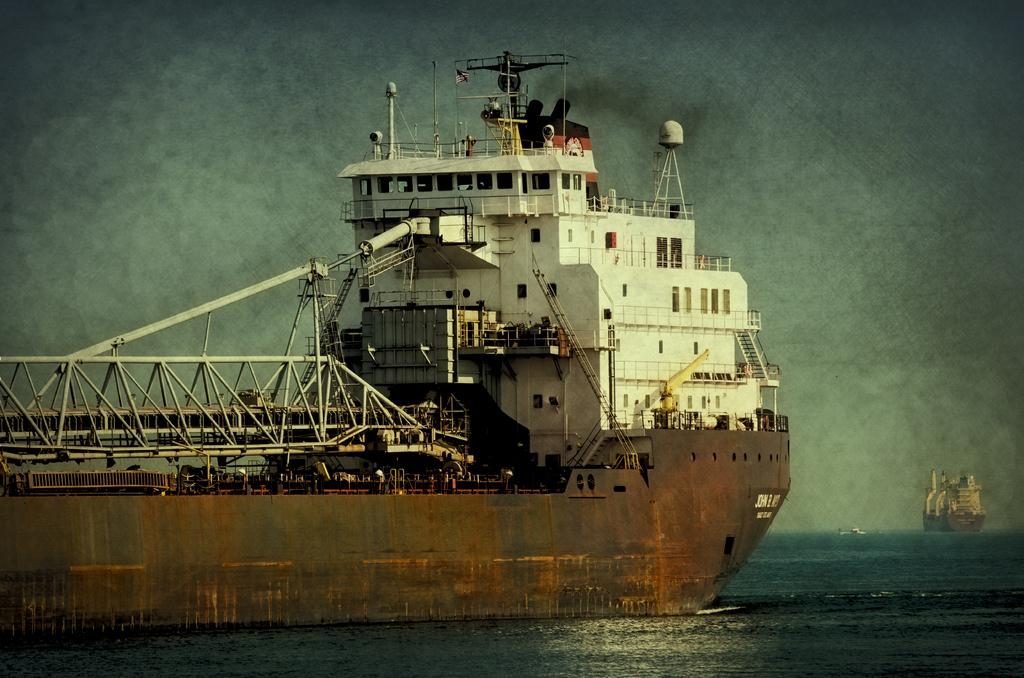What are the people in the image doing? The people in the image are in a boat. What is the primary setting of the image? There is water visible in the image. What else can be seen in the sky? There is sky visible in the image. What type of structure is present in the image? There is at least one building in the image. What feature can be seen on the building? There are windows in the image. What type of balls are being used for a game in the image? There are no balls or games present in the image; it features people in a boat on water with a building and sky visible. 